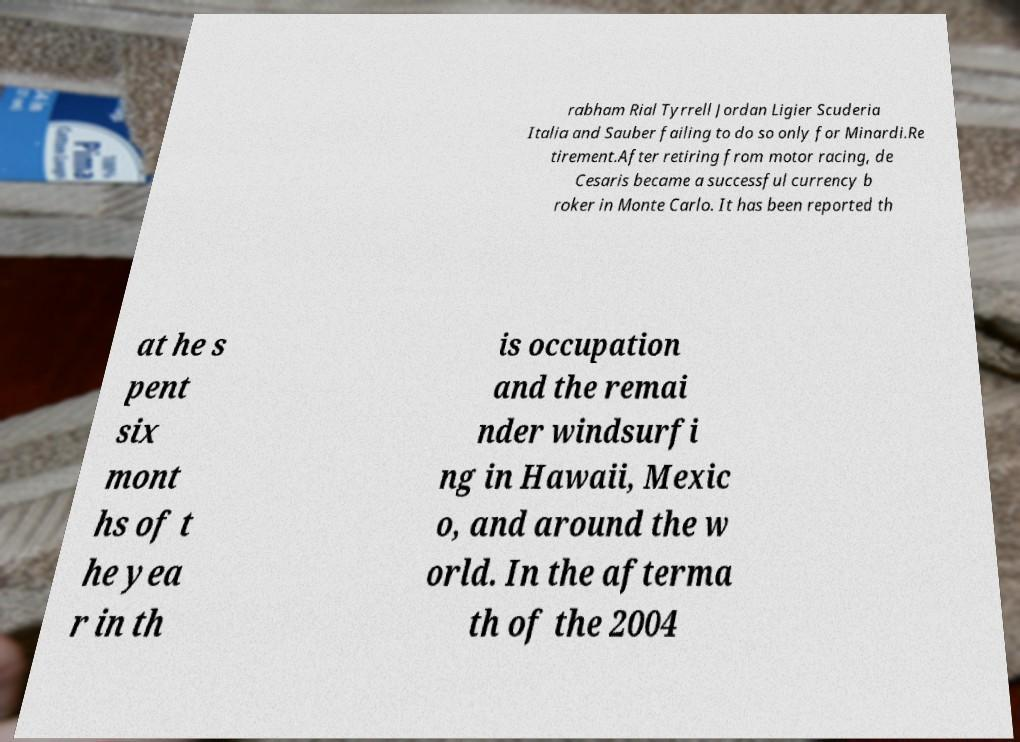Please identify and transcribe the text found in this image. rabham Rial Tyrrell Jordan Ligier Scuderia Italia and Sauber failing to do so only for Minardi.Re tirement.After retiring from motor racing, de Cesaris became a successful currency b roker in Monte Carlo. It has been reported th at he s pent six mont hs of t he yea r in th is occupation and the remai nder windsurfi ng in Hawaii, Mexic o, and around the w orld. In the afterma th of the 2004 